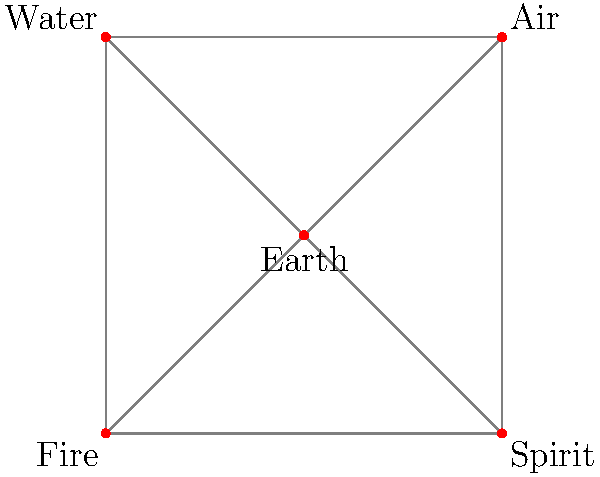In the given vertex-edge graph representing a ritual circle, how many triangles (3-cycles) are formed by the interconnected elements? To determine the number of triangles in this ritual circle graph, we need to follow these steps:

1. Identify the vertices: There are 5 vertices representing Earth, Air, Water, Fire, and Spirit.

2. Understand the graph's structure: Every vertex is connected to every other vertex, forming a complete graph K5.

3. Calculate the number of triangles:
   a) In a complete graph with n vertices, the number of triangles is given by the formula:
      $$ \text{Number of triangles} = \binom{n}{3} = \frac{n(n-1)(n-2)}{6} $$
   
   b) In this case, n = 5, so we calculate:
      $$ \binom{5}{3} = \frac{5(5-1)(5-2)}{6} = \frac{5 \cdot 4 \cdot 3}{6} = \frac{60}{6} = 10 $$

4. Interpret the result: There are 10 triangles formed by the interconnected elements in this ritual circle.

5. Esoteric significance: In hermetic traditions, the number 10 is associated with the Tetractys, a triangular figure consisting of ten points arranged in four rows. This connection between the graph structure and sacred geometry reinforces the magical potency of the ritual circle.
Answer: 10 triangles 